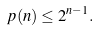Convert formula to latex. <formula><loc_0><loc_0><loc_500><loc_500>p ( n ) \leq 2 ^ { n - 1 } .</formula> 